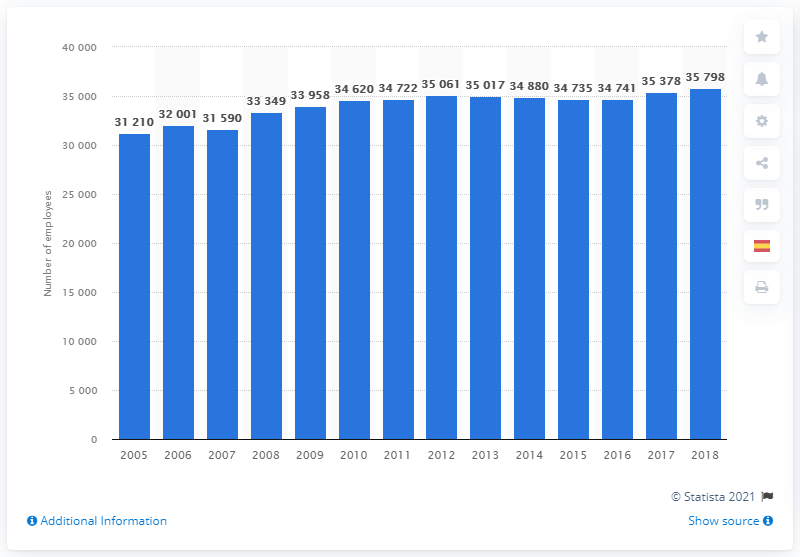Mention a couple of crucial points in this snapshot. In 2018, there were 35,798 general practitioners employed in Spain. 